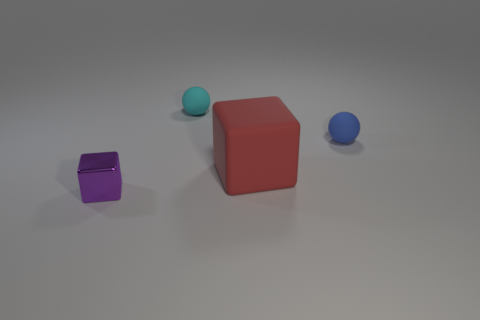Add 4 red cylinders. How many objects exist? 8 Subtract all large rubber blocks. Subtract all tiny purple cubes. How many objects are left? 2 Add 1 red objects. How many red objects are left? 2 Add 4 metal cubes. How many metal cubes exist? 5 Subtract 0 green cylinders. How many objects are left? 4 